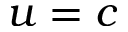<formula> <loc_0><loc_0><loc_500><loc_500>u = c</formula> 